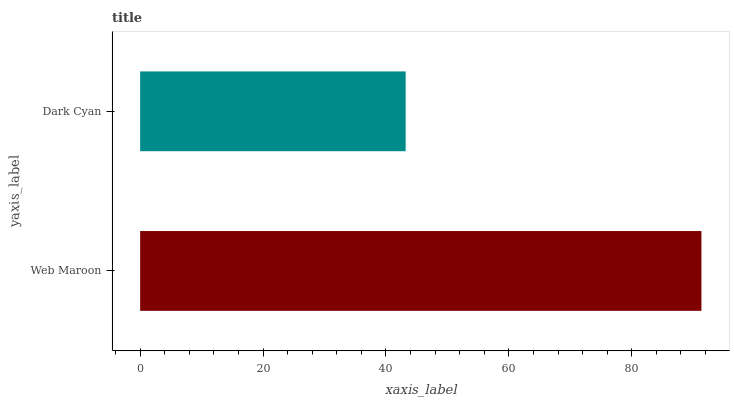Is Dark Cyan the minimum?
Answer yes or no. Yes. Is Web Maroon the maximum?
Answer yes or no. Yes. Is Dark Cyan the maximum?
Answer yes or no. No. Is Web Maroon greater than Dark Cyan?
Answer yes or no. Yes. Is Dark Cyan less than Web Maroon?
Answer yes or no. Yes. Is Dark Cyan greater than Web Maroon?
Answer yes or no. No. Is Web Maroon less than Dark Cyan?
Answer yes or no. No. Is Web Maroon the high median?
Answer yes or no. Yes. Is Dark Cyan the low median?
Answer yes or no. Yes. Is Dark Cyan the high median?
Answer yes or no. No. Is Web Maroon the low median?
Answer yes or no. No. 